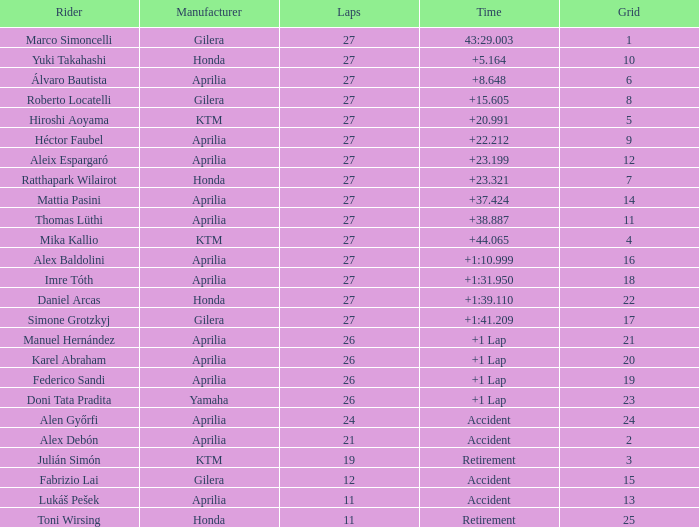Which maker has a time of mishap and a grid exceeding 15? Aprilia. 